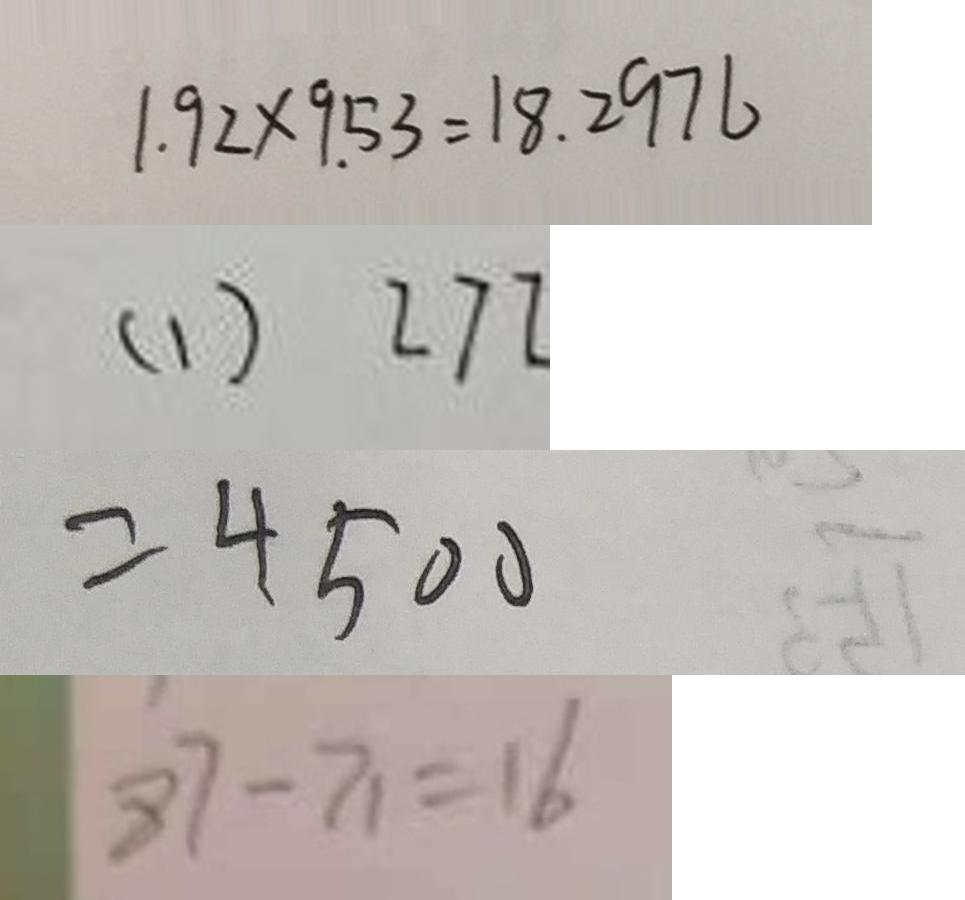<formula> <loc_0><loc_0><loc_500><loc_500>1 . 9 2 \times 9 . 5 3 = 1 8 . 2 9 7 6 
 ( 1 ) 2 7 2 
 = 4 5 0 0 
 8 7 - 7 1 = 1 6</formula> 